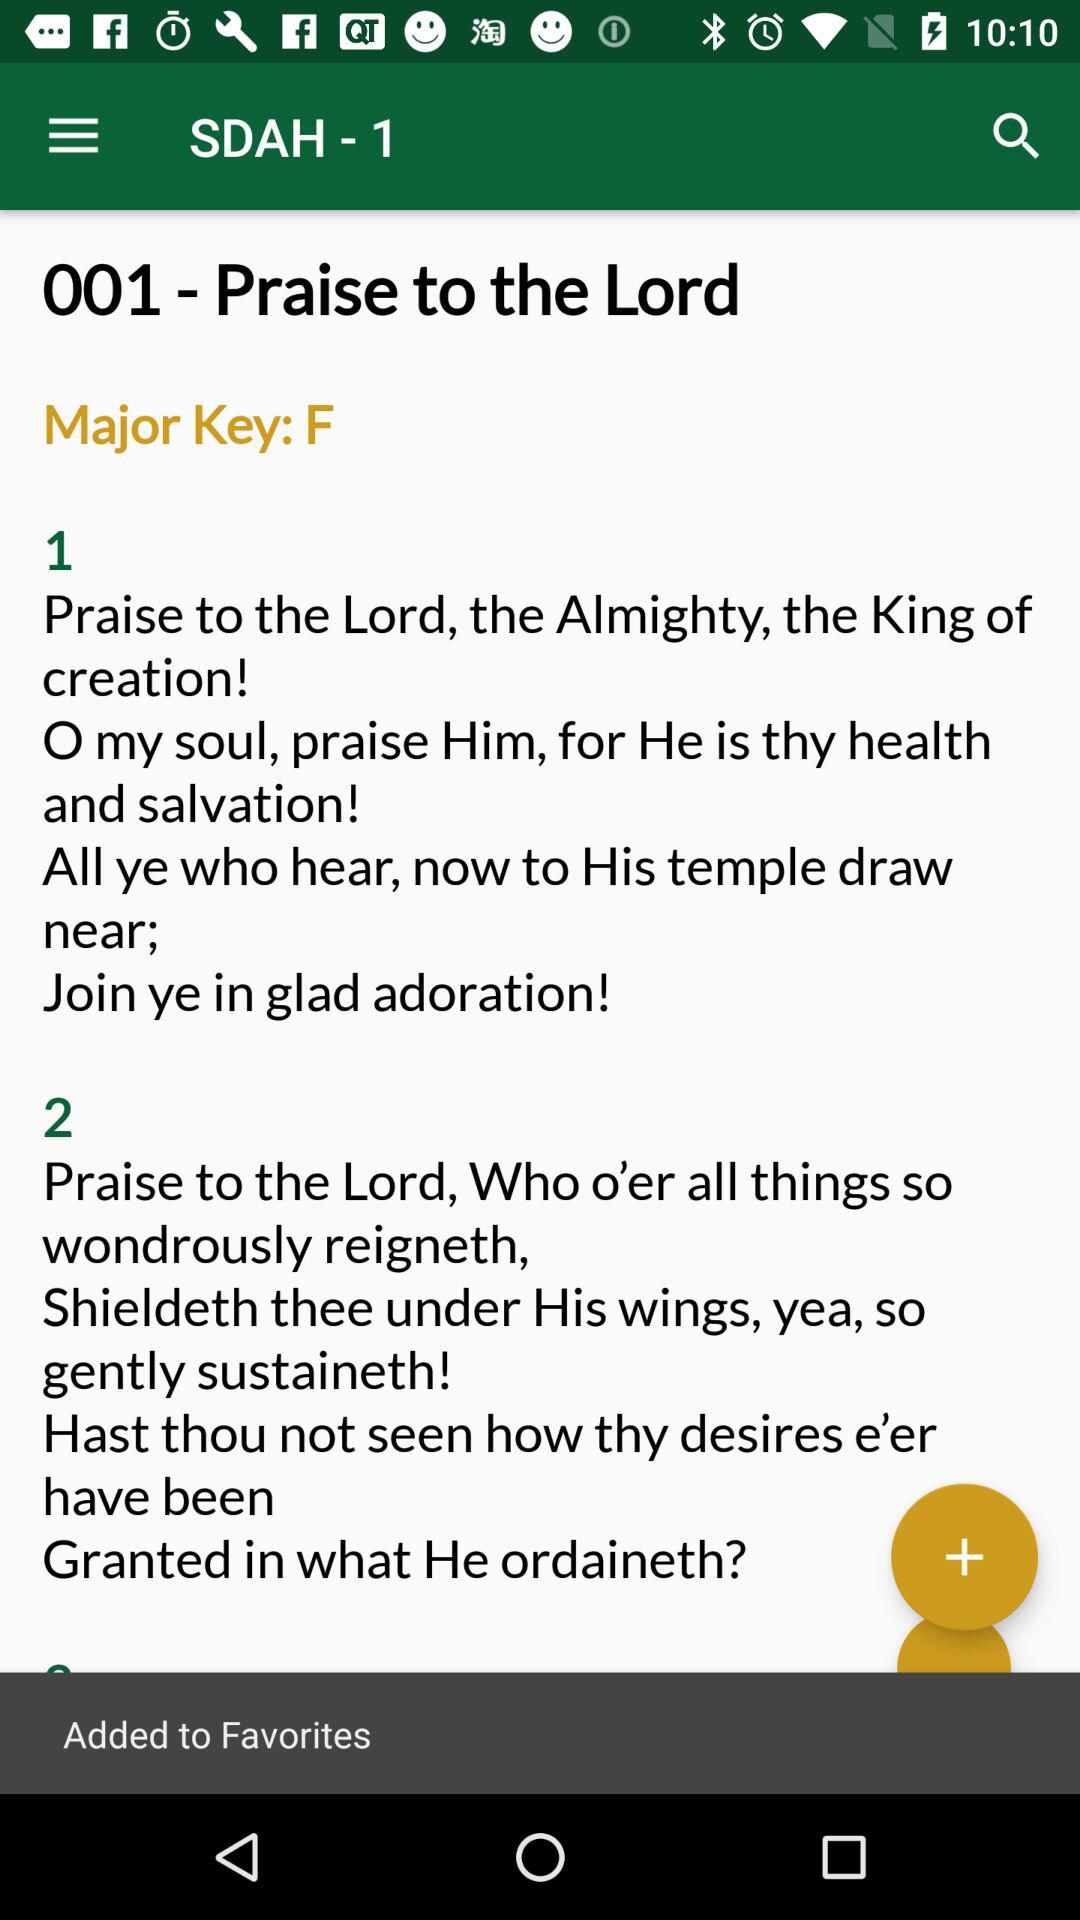How many verses are in the song?
Answer the question using a single word or phrase. 2 